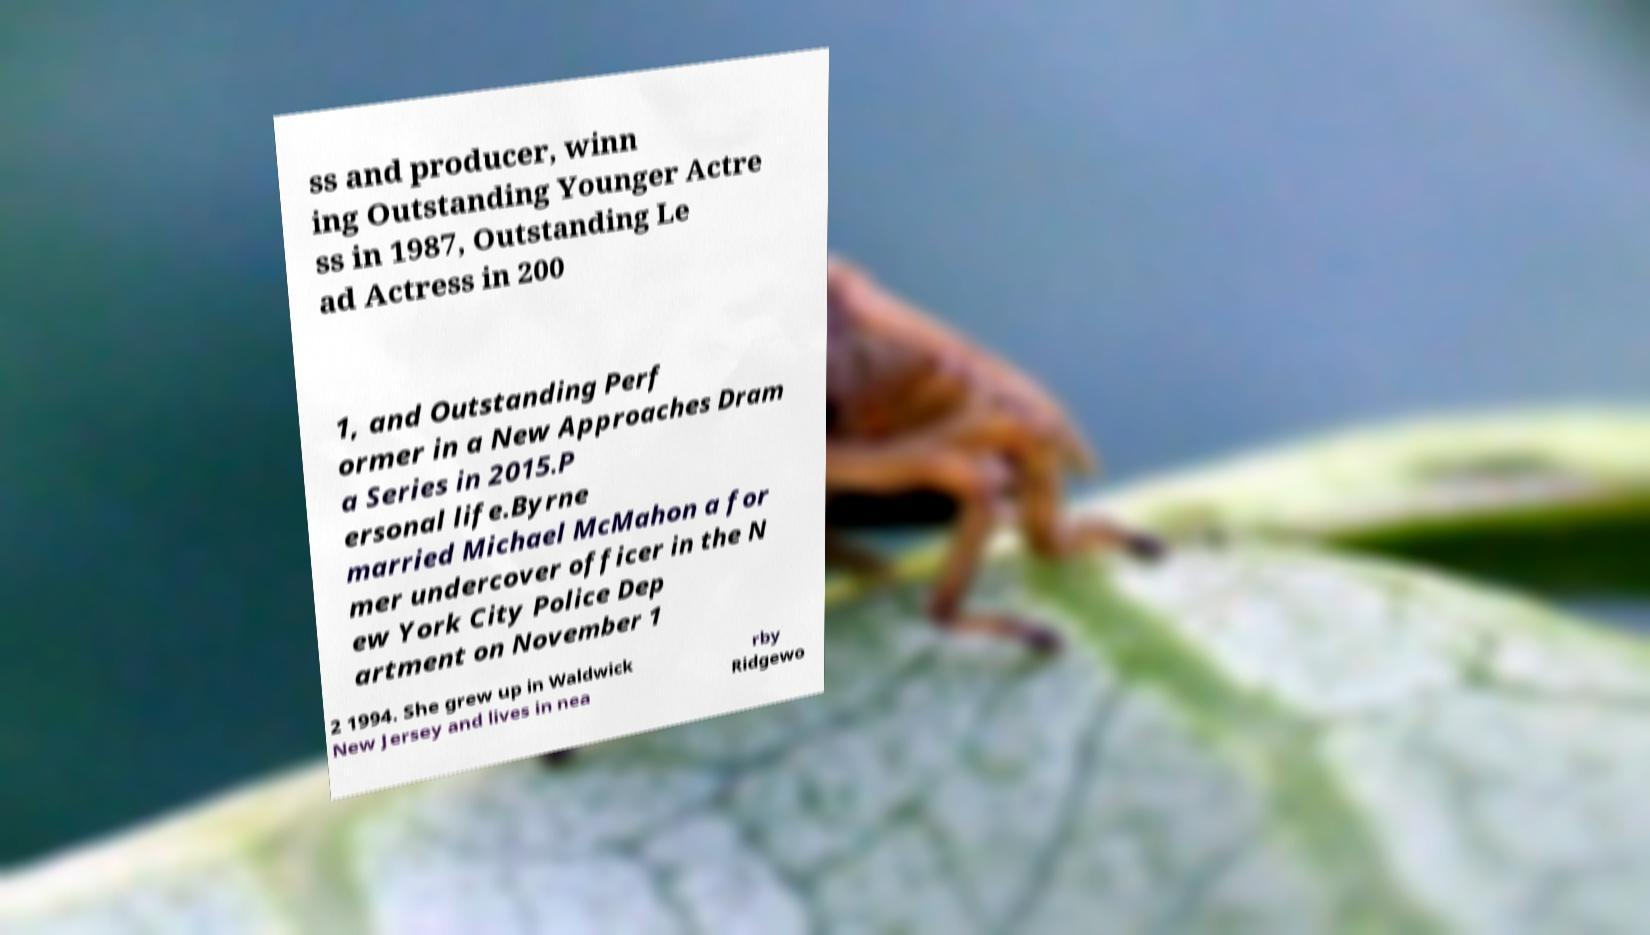Could you extract and type out the text from this image? ss and producer, winn ing Outstanding Younger Actre ss in 1987, Outstanding Le ad Actress in 200 1, and Outstanding Perf ormer in a New Approaches Dram a Series in 2015.P ersonal life.Byrne married Michael McMahon a for mer undercover officer in the N ew York City Police Dep artment on November 1 2 1994. She grew up in Waldwick New Jersey and lives in nea rby Ridgewo 